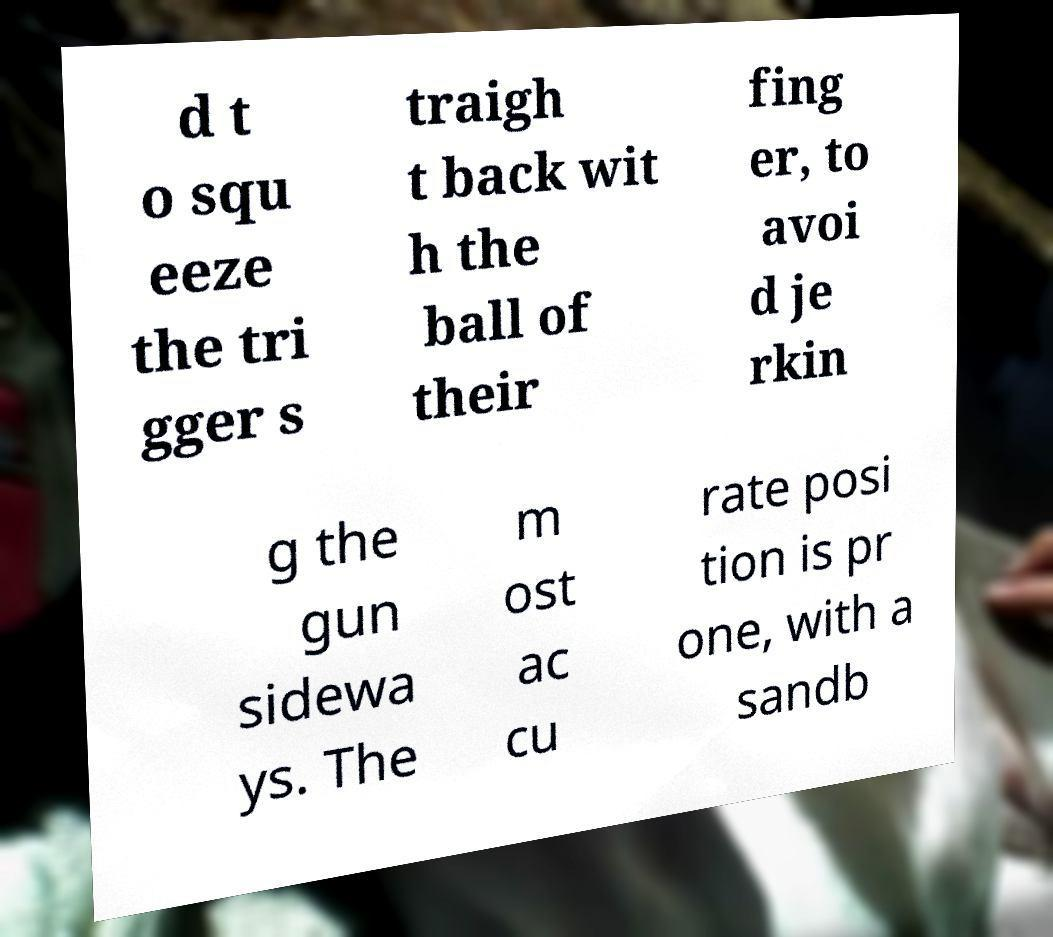Could you assist in decoding the text presented in this image and type it out clearly? d t o squ eeze the tri gger s traigh t back wit h the ball of their fing er, to avoi d je rkin g the gun sidewa ys. The m ost ac cu rate posi tion is pr one, with a sandb 